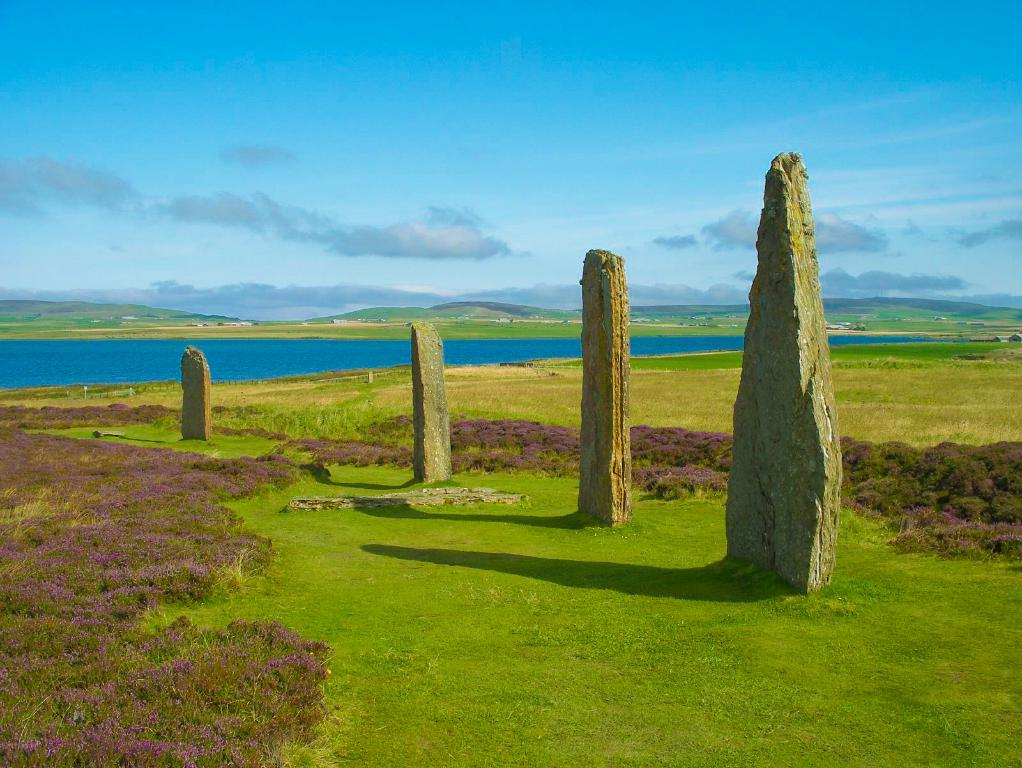What type of natural elements can be seen in the image? There are rocks, grass, and water visible in the image. What is visible in the background of the image? The sky is visible in the image. What can be observed in the sky? Clouds are present in the sky. Is there a family playing basketball on the rocks in the image? No, there is no family or basketball present in the image; it features rocks, grass, water, and a sky with clouds. 